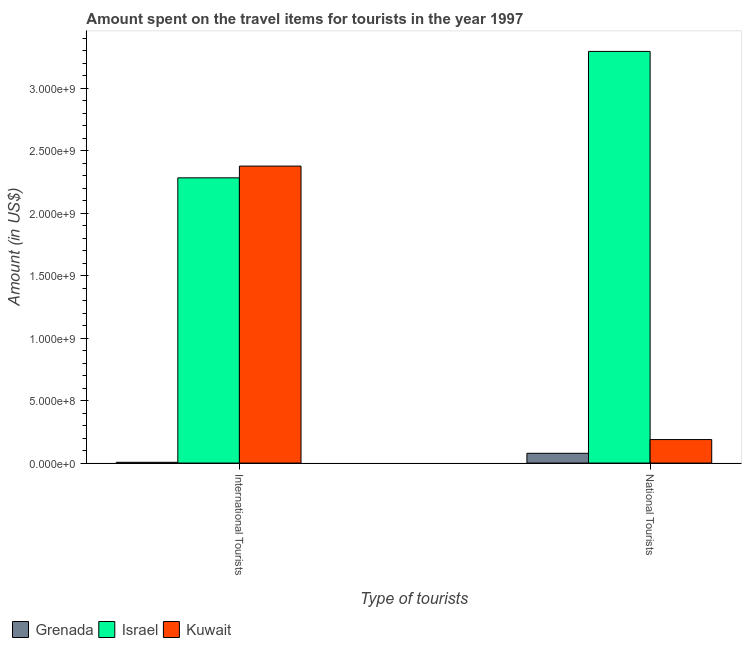How many groups of bars are there?
Provide a short and direct response. 2. How many bars are there on the 1st tick from the left?
Offer a very short reply. 3. What is the label of the 1st group of bars from the left?
Ensure brevity in your answer.  International Tourists. What is the amount spent on travel items of national tourists in Kuwait?
Keep it short and to the point. 1.88e+08. Across all countries, what is the maximum amount spent on travel items of international tourists?
Your response must be concise. 2.38e+09. Across all countries, what is the minimum amount spent on travel items of national tourists?
Your answer should be very brief. 7.80e+07. In which country was the amount spent on travel items of national tourists maximum?
Your answer should be compact. Israel. In which country was the amount spent on travel items of international tourists minimum?
Keep it short and to the point. Grenada. What is the total amount spent on travel items of international tourists in the graph?
Offer a terse response. 4.67e+09. What is the difference between the amount spent on travel items of international tourists in Israel and that in Kuwait?
Provide a succinct answer. -9.40e+07. What is the difference between the amount spent on travel items of international tourists in Israel and the amount spent on travel items of national tourists in Grenada?
Give a very brief answer. 2.20e+09. What is the average amount spent on travel items of international tourists per country?
Keep it short and to the point. 1.56e+09. What is the difference between the amount spent on travel items of national tourists and amount spent on travel items of international tourists in Grenada?
Your answer should be compact. 7.20e+07. What is the ratio of the amount spent on travel items of national tourists in Kuwait to that in Grenada?
Your answer should be very brief. 2.41. Is the amount spent on travel items of international tourists in Israel less than that in Kuwait?
Keep it short and to the point. Yes. In how many countries, is the amount spent on travel items of international tourists greater than the average amount spent on travel items of international tourists taken over all countries?
Give a very brief answer. 2. What does the 1st bar from the left in International Tourists represents?
Keep it short and to the point. Grenada. What does the 3rd bar from the right in National Tourists represents?
Your answer should be compact. Grenada. How many bars are there?
Provide a succinct answer. 6. Are all the bars in the graph horizontal?
Your answer should be very brief. No. How many countries are there in the graph?
Offer a terse response. 3. Where does the legend appear in the graph?
Make the answer very short. Bottom left. How many legend labels are there?
Give a very brief answer. 3. What is the title of the graph?
Ensure brevity in your answer.  Amount spent on the travel items for tourists in the year 1997. What is the label or title of the X-axis?
Your answer should be very brief. Type of tourists. What is the label or title of the Y-axis?
Make the answer very short. Amount (in US$). What is the Amount (in US$) in Israel in International Tourists?
Provide a short and direct response. 2.28e+09. What is the Amount (in US$) of Kuwait in International Tourists?
Keep it short and to the point. 2.38e+09. What is the Amount (in US$) of Grenada in National Tourists?
Ensure brevity in your answer.  7.80e+07. What is the Amount (in US$) of Israel in National Tourists?
Provide a succinct answer. 3.30e+09. What is the Amount (in US$) in Kuwait in National Tourists?
Ensure brevity in your answer.  1.88e+08. Across all Type of tourists, what is the maximum Amount (in US$) in Grenada?
Your answer should be very brief. 7.80e+07. Across all Type of tourists, what is the maximum Amount (in US$) of Israel?
Your answer should be very brief. 3.30e+09. Across all Type of tourists, what is the maximum Amount (in US$) of Kuwait?
Keep it short and to the point. 2.38e+09. Across all Type of tourists, what is the minimum Amount (in US$) of Grenada?
Make the answer very short. 6.00e+06. Across all Type of tourists, what is the minimum Amount (in US$) of Israel?
Your answer should be compact. 2.28e+09. Across all Type of tourists, what is the minimum Amount (in US$) in Kuwait?
Keep it short and to the point. 1.88e+08. What is the total Amount (in US$) in Grenada in the graph?
Your response must be concise. 8.40e+07. What is the total Amount (in US$) in Israel in the graph?
Keep it short and to the point. 5.58e+09. What is the total Amount (in US$) in Kuwait in the graph?
Keep it short and to the point. 2.56e+09. What is the difference between the Amount (in US$) of Grenada in International Tourists and that in National Tourists?
Provide a succinct answer. -7.20e+07. What is the difference between the Amount (in US$) in Israel in International Tourists and that in National Tourists?
Give a very brief answer. -1.01e+09. What is the difference between the Amount (in US$) of Kuwait in International Tourists and that in National Tourists?
Your answer should be compact. 2.19e+09. What is the difference between the Amount (in US$) in Grenada in International Tourists and the Amount (in US$) in Israel in National Tourists?
Your response must be concise. -3.29e+09. What is the difference between the Amount (in US$) in Grenada in International Tourists and the Amount (in US$) in Kuwait in National Tourists?
Make the answer very short. -1.82e+08. What is the difference between the Amount (in US$) in Israel in International Tourists and the Amount (in US$) in Kuwait in National Tourists?
Offer a terse response. 2.10e+09. What is the average Amount (in US$) in Grenada per Type of tourists?
Provide a succinct answer. 4.20e+07. What is the average Amount (in US$) of Israel per Type of tourists?
Provide a succinct answer. 2.79e+09. What is the average Amount (in US$) in Kuwait per Type of tourists?
Ensure brevity in your answer.  1.28e+09. What is the difference between the Amount (in US$) of Grenada and Amount (in US$) of Israel in International Tourists?
Offer a very short reply. -2.28e+09. What is the difference between the Amount (in US$) in Grenada and Amount (in US$) in Kuwait in International Tourists?
Offer a very short reply. -2.37e+09. What is the difference between the Amount (in US$) in Israel and Amount (in US$) in Kuwait in International Tourists?
Keep it short and to the point. -9.40e+07. What is the difference between the Amount (in US$) of Grenada and Amount (in US$) of Israel in National Tourists?
Your response must be concise. -3.22e+09. What is the difference between the Amount (in US$) of Grenada and Amount (in US$) of Kuwait in National Tourists?
Keep it short and to the point. -1.10e+08. What is the difference between the Amount (in US$) in Israel and Amount (in US$) in Kuwait in National Tourists?
Offer a terse response. 3.11e+09. What is the ratio of the Amount (in US$) in Grenada in International Tourists to that in National Tourists?
Your answer should be compact. 0.08. What is the ratio of the Amount (in US$) of Israel in International Tourists to that in National Tourists?
Provide a short and direct response. 0.69. What is the ratio of the Amount (in US$) in Kuwait in International Tourists to that in National Tourists?
Your response must be concise. 12.64. What is the difference between the highest and the second highest Amount (in US$) of Grenada?
Your response must be concise. 7.20e+07. What is the difference between the highest and the second highest Amount (in US$) in Israel?
Provide a short and direct response. 1.01e+09. What is the difference between the highest and the second highest Amount (in US$) of Kuwait?
Provide a succinct answer. 2.19e+09. What is the difference between the highest and the lowest Amount (in US$) of Grenada?
Give a very brief answer. 7.20e+07. What is the difference between the highest and the lowest Amount (in US$) in Israel?
Keep it short and to the point. 1.01e+09. What is the difference between the highest and the lowest Amount (in US$) in Kuwait?
Your response must be concise. 2.19e+09. 